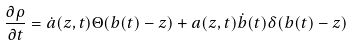Convert formula to latex. <formula><loc_0><loc_0><loc_500><loc_500>\frac { \partial \rho } { \partial t } = \dot { a } ( z , t ) \Theta ( b ( t ) - z ) + a ( z , t ) \dot { b } ( t ) \delta ( b ( t ) - z )</formula> 